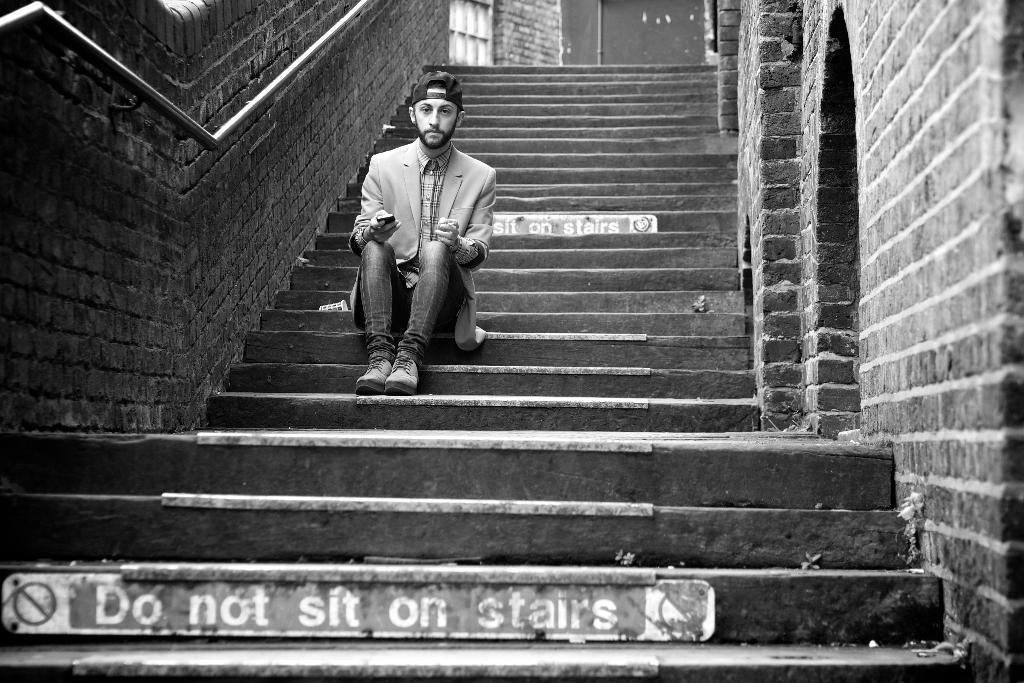How would you summarize this image in a sentence or two? This is a black and white image, in this image in the center there is one person who is sitting on stairs. In the center there are some stairs, and on the right side and left side there is wall. 